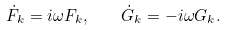Convert formula to latex. <formula><loc_0><loc_0><loc_500><loc_500>\dot { F } _ { k } = i \omega F _ { k } , \quad \dot { G } _ { k } = - i \omega G _ { k } .</formula> 